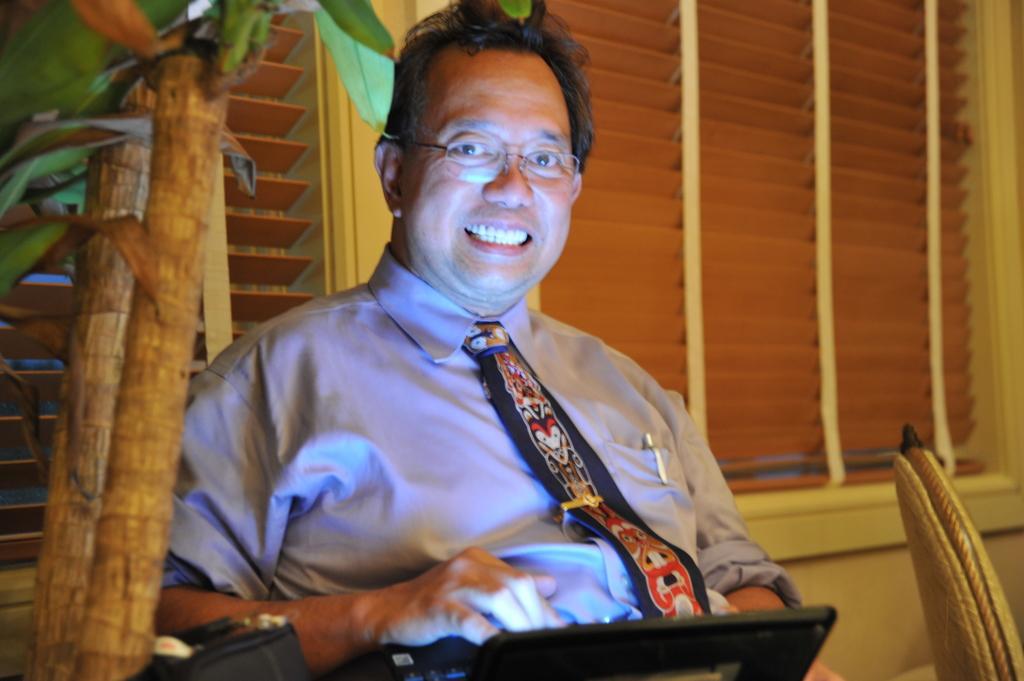In one or two sentences, can you explain what this image depicts? In this image, we can see a man is smiling and wearing glasses. On the left side, we can see plants. At the bottom, we can see few black color objects. Background we can see window shades. 